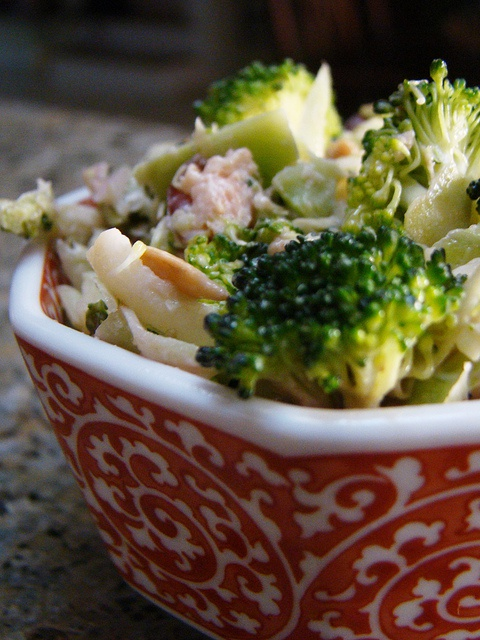Describe the objects in this image and their specific colors. I can see dining table in black, maroon, gray, and olive tones, bowl in black, maroon, olive, and gray tones, broccoli in black, darkgreen, and olive tones, broccoli in black, olive, and beige tones, and broccoli in black, beige, khaki, and darkgreen tones in this image. 